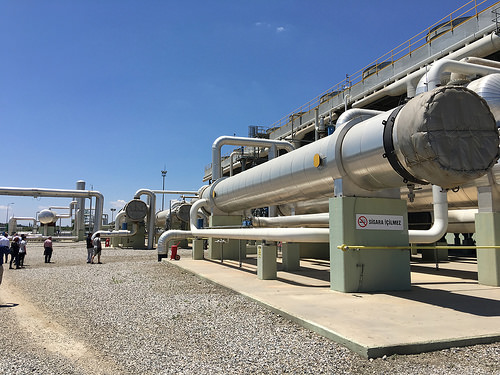<image>
Is the tower behind the pvc? Yes. From this viewpoint, the tower is positioned behind the pvc, with the pvc partially or fully occluding the tower. 